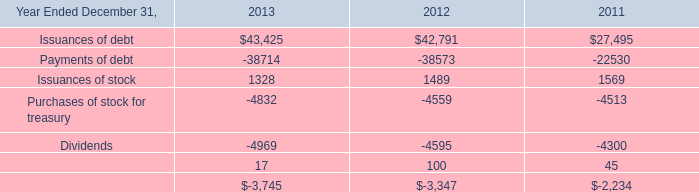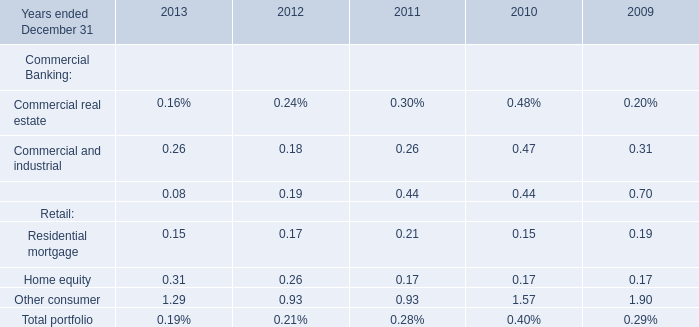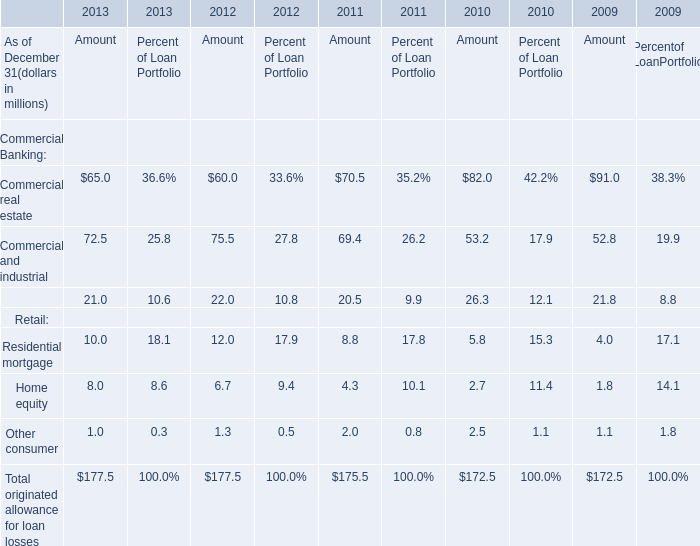What's the sum of the Equipment financing for Commercial Banking in the years where Equipment financing for Amoun is positive? 
Computations: ((((0.08 + 0.19) + 0.44) + 0.44) + 0.70)
Answer: 1.85. 